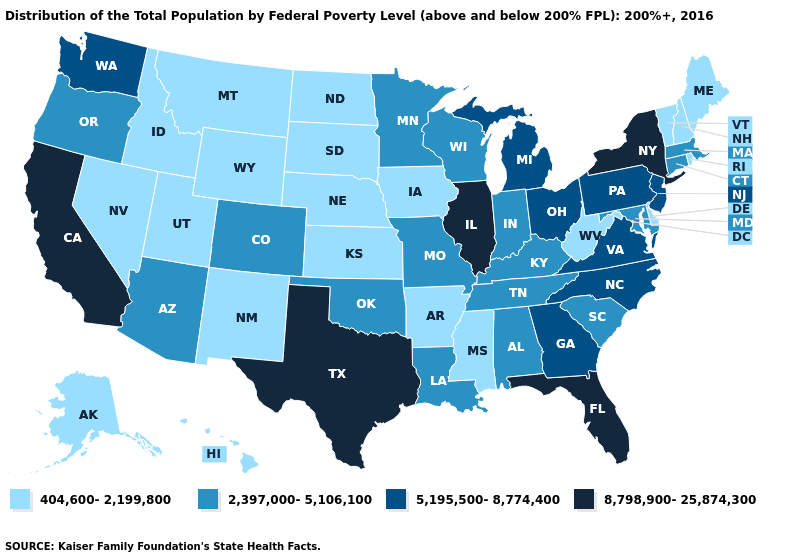Name the states that have a value in the range 404,600-2,199,800?
Concise answer only. Alaska, Arkansas, Delaware, Hawaii, Idaho, Iowa, Kansas, Maine, Mississippi, Montana, Nebraska, Nevada, New Hampshire, New Mexico, North Dakota, Rhode Island, South Dakota, Utah, Vermont, West Virginia, Wyoming. What is the highest value in states that border Connecticut?
Give a very brief answer. 8,798,900-25,874,300. Name the states that have a value in the range 5,195,500-8,774,400?
Give a very brief answer. Georgia, Michigan, New Jersey, North Carolina, Ohio, Pennsylvania, Virginia, Washington. Does California have the highest value in the West?
Short answer required. Yes. What is the value of South Carolina?
Write a very short answer. 2,397,000-5,106,100. Name the states that have a value in the range 8,798,900-25,874,300?
Concise answer only. California, Florida, Illinois, New York, Texas. Does Oklahoma have the lowest value in the USA?
Be succinct. No. What is the highest value in states that border Indiana?
Quick response, please. 8,798,900-25,874,300. Does Nevada have the lowest value in the West?
Answer briefly. Yes. Name the states that have a value in the range 2,397,000-5,106,100?
Concise answer only. Alabama, Arizona, Colorado, Connecticut, Indiana, Kentucky, Louisiana, Maryland, Massachusetts, Minnesota, Missouri, Oklahoma, Oregon, South Carolina, Tennessee, Wisconsin. How many symbols are there in the legend?
Write a very short answer. 4. Name the states that have a value in the range 5,195,500-8,774,400?
Be succinct. Georgia, Michigan, New Jersey, North Carolina, Ohio, Pennsylvania, Virginia, Washington. Does the first symbol in the legend represent the smallest category?
Concise answer only. Yes. Does New Hampshire have the lowest value in the Northeast?
Give a very brief answer. Yes. Name the states that have a value in the range 404,600-2,199,800?
Answer briefly. Alaska, Arkansas, Delaware, Hawaii, Idaho, Iowa, Kansas, Maine, Mississippi, Montana, Nebraska, Nevada, New Hampshire, New Mexico, North Dakota, Rhode Island, South Dakota, Utah, Vermont, West Virginia, Wyoming. 